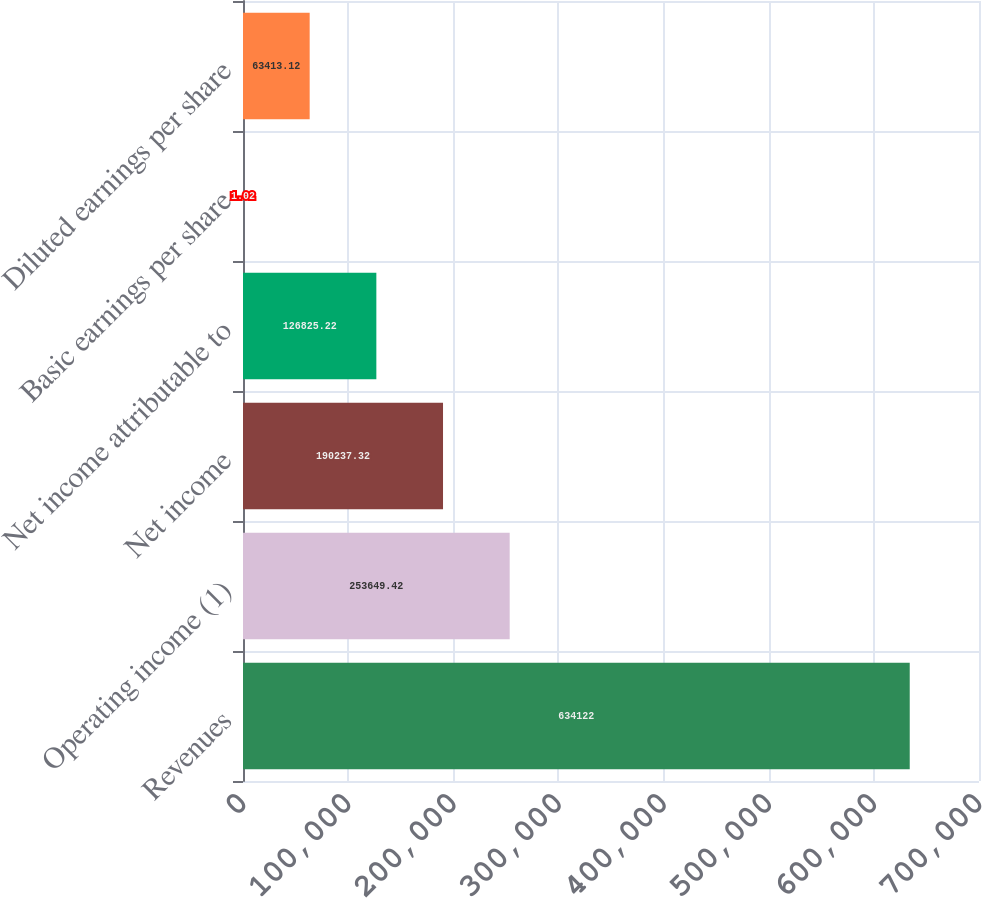Convert chart. <chart><loc_0><loc_0><loc_500><loc_500><bar_chart><fcel>Revenues<fcel>Operating income (1)<fcel>Net income<fcel>Net income attributable to<fcel>Basic earnings per share<fcel>Diluted earnings per share<nl><fcel>634122<fcel>253649<fcel>190237<fcel>126825<fcel>1.02<fcel>63413.1<nl></chart> 